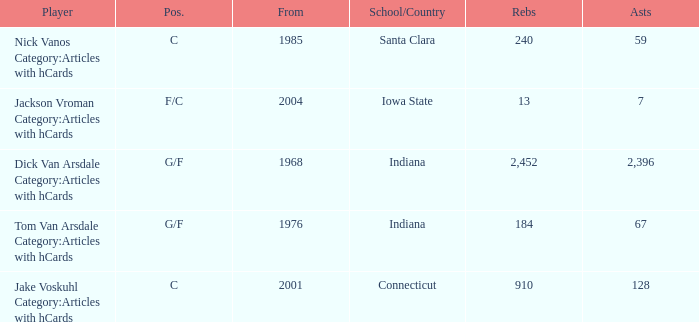What is the average rebounds for players from 1976 and over 67 assists? None. 